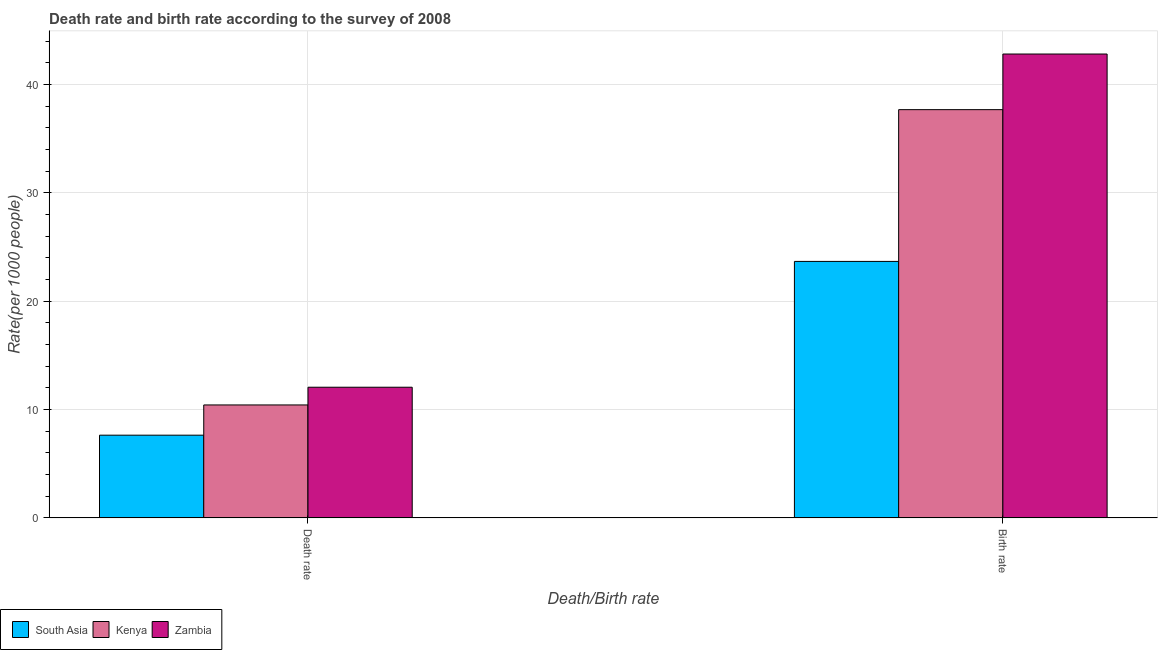Are the number of bars per tick equal to the number of legend labels?
Offer a very short reply. Yes. What is the label of the 1st group of bars from the left?
Offer a terse response. Death rate. What is the death rate in Kenya?
Give a very brief answer. 10.42. Across all countries, what is the maximum birth rate?
Ensure brevity in your answer.  42.81. Across all countries, what is the minimum birth rate?
Provide a short and direct response. 23.67. In which country was the birth rate maximum?
Your answer should be compact. Zambia. In which country was the death rate minimum?
Provide a succinct answer. South Asia. What is the total birth rate in the graph?
Keep it short and to the point. 104.16. What is the difference between the death rate in Kenya and that in Zambia?
Give a very brief answer. -1.64. What is the difference between the death rate in Kenya and the birth rate in South Asia?
Provide a short and direct response. -13.25. What is the average death rate per country?
Your answer should be very brief. 10.04. What is the difference between the death rate and birth rate in Zambia?
Offer a terse response. -30.75. In how many countries, is the death rate greater than 36 ?
Ensure brevity in your answer.  0. What is the ratio of the death rate in Zambia to that in Kenya?
Your answer should be very brief. 1.16. In how many countries, is the death rate greater than the average death rate taken over all countries?
Your response must be concise. 2. What does the 2nd bar from the left in Birth rate represents?
Keep it short and to the point. Kenya. How many bars are there?
Your answer should be compact. 6. Are all the bars in the graph horizontal?
Keep it short and to the point. No. How many legend labels are there?
Offer a terse response. 3. What is the title of the graph?
Offer a very short reply. Death rate and birth rate according to the survey of 2008. Does "Venezuela" appear as one of the legend labels in the graph?
Ensure brevity in your answer.  No. What is the label or title of the X-axis?
Your answer should be compact. Death/Birth rate. What is the label or title of the Y-axis?
Your response must be concise. Rate(per 1000 people). What is the Rate(per 1000 people) in South Asia in Death rate?
Provide a short and direct response. 7.63. What is the Rate(per 1000 people) in Kenya in Death rate?
Your answer should be compact. 10.42. What is the Rate(per 1000 people) of Zambia in Death rate?
Your answer should be very brief. 12.06. What is the Rate(per 1000 people) of South Asia in Birth rate?
Keep it short and to the point. 23.67. What is the Rate(per 1000 people) in Kenya in Birth rate?
Provide a succinct answer. 37.68. What is the Rate(per 1000 people) of Zambia in Birth rate?
Make the answer very short. 42.81. Across all Death/Birth rate, what is the maximum Rate(per 1000 people) in South Asia?
Your answer should be very brief. 23.67. Across all Death/Birth rate, what is the maximum Rate(per 1000 people) of Kenya?
Your answer should be compact. 37.68. Across all Death/Birth rate, what is the maximum Rate(per 1000 people) of Zambia?
Give a very brief answer. 42.81. Across all Death/Birth rate, what is the minimum Rate(per 1000 people) in South Asia?
Your answer should be compact. 7.63. Across all Death/Birth rate, what is the minimum Rate(per 1000 people) of Kenya?
Keep it short and to the point. 10.42. Across all Death/Birth rate, what is the minimum Rate(per 1000 people) of Zambia?
Offer a very short reply. 12.06. What is the total Rate(per 1000 people) of South Asia in the graph?
Make the answer very short. 31.3. What is the total Rate(per 1000 people) of Kenya in the graph?
Offer a very short reply. 48.1. What is the total Rate(per 1000 people) of Zambia in the graph?
Ensure brevity in your answer.  54.87. What is the difference between the Rate(per 1000 people) in South Asia in Death rate and that in Birth rate?
Offer a terse response. -16.04. What is the difference between the Rate(per 1000 people) in Kenya in Death rate and that in Birth rate?
Keep it short and to the point. -27.25. What is the difference between the Rate(per 1000 people) in Zambia in Death rate and that in Birth rate?
Provide a short and direct response. -30.75. What is the difference between the Rate(per 1000 people) in South Asia in Death rate and the Rate(per 1000 people) in Kenya in Birth rate?
Keep it short and to the point. -30.04. What is the difference between the Rate(per 1000 people) in South Asia in Death rate and the Rate(per 1000 people) in Zambia in Birth rate?
Provide a succinct answer. -35.18. What is the difference between the Rate(per 1000 people) of Kenya in Death rate and the Rate(per 1000 people) of Zambia in Birth rate?
Provide a short and direct response. -32.39. What is the average Rate(per 1000 people) in South Asia per Death/Birth rate?
Provide a succinct answer. 15.65. What is the average Rate(per 1000 people) in Kenya per Death/Birth rate?
Your answer should be very brief. 24.05. What is the average Rate(per 1000 people) in Zambia per Death/Birth rate?
Make the answer very short. 27.43. What is the difference between the Rate(per 1000 people) of South Asia and Rate(per 1000 people) of Kenya in Death rate?
Keep it short and to the point. -2.79. What is the difference between the Rate(per 1000 people) in South Asia and Rate(per 1000 people) in Zambia in Death rate?
Keep it short and to the point. -4.43. What is the difference between the Rate(per 1000 people) in Kenya and Rate(per 1000 people) in Zambia in Death rate?
Your response must be concise. -1.64. What is the difference between the Rate(per 1000 people) of South Asia and Rate(per 1000 people) of Kenya in Birth rate?
Ensure brevity in your answer.  -14.01. What is the difference between the Rate(per 1000 people) in South Asia and Rate(per 1000 people) in Zambia in Birth rate?
Keep it short and to the point. -19.14. What is the difference between the Rate(per 1000 people) of Kenya and Rate(per 1000 people) of Zambia in Birth rate?
Offer a very short reply. -5.13. What is the ratio of the Rate(per 1000 people) in South Asia in Death rate to that in Birth rate?
Offer a terse response. 0.32. What is the ratio of the Rate(per 1000 people) in Kenya in Death rate to that in Birth rate?
Ensure brevity in your answer.  0.28. What is the ratio of the Rate(per 1000 people) in Zambia in Death rate to that in Birth rate?
Your answer should be very brief. 0.28. What is the difference between the highest and the second highest Rate(per 1000 people) of South Asia?
Provide a succinct answer. 16.04. What is the difference between the highest and the second highest Rate(per 1000 people) of Kenya?
Give a very brief answer. 27.25. What is the difference between the highest and the second highest Rate(per 1000 people) in Zambia?
Your answer should be very brief. 30.75. What is the difference between the highest and the lowest Rate(per 1000 people) in South Asia?
Your response must be concise. 16.04. What is the difference between the highest and the lowest Rate(per 1000 people) in Kenya?
Your response must be concise. 27.25. What is the difference between the highest and the lowest Rate(per 1000 people) in Zambia?
Give a very brief answer. 30.75. 